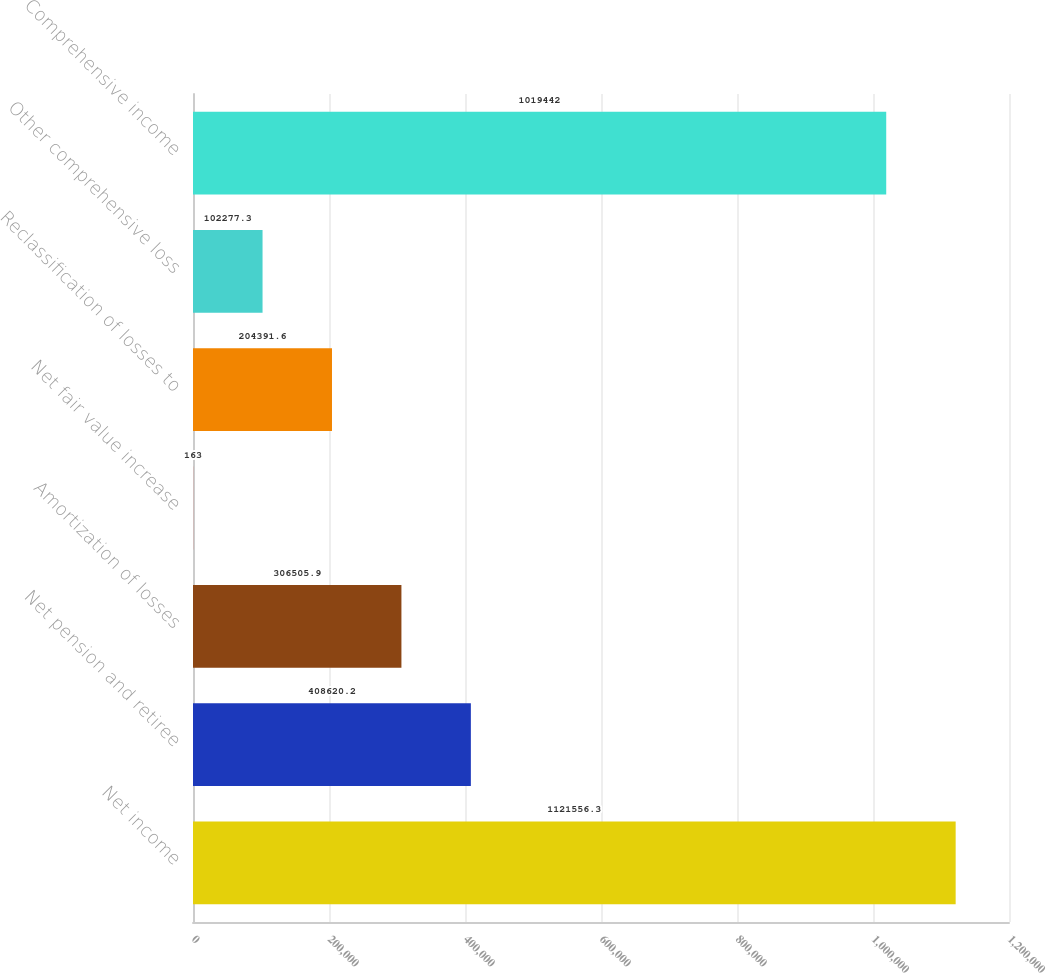<chart> <loc_0><loc_0><loc_500><loc_500><bar_chart><fcel>Net income<fcel>Net pension and retiree<fcel>Amortization of losses<fcel>Net fair value increase<fcel>Reclassification of losses to<fcel>Other comprehensive loss<fcel>Comprehensive income<nl><fcel>1.12156e+06<fcel>408620<fcel>306506<fcel>163<fcel>204392<fcel>102277<fcel>1.01944e+06<nl></chart> 